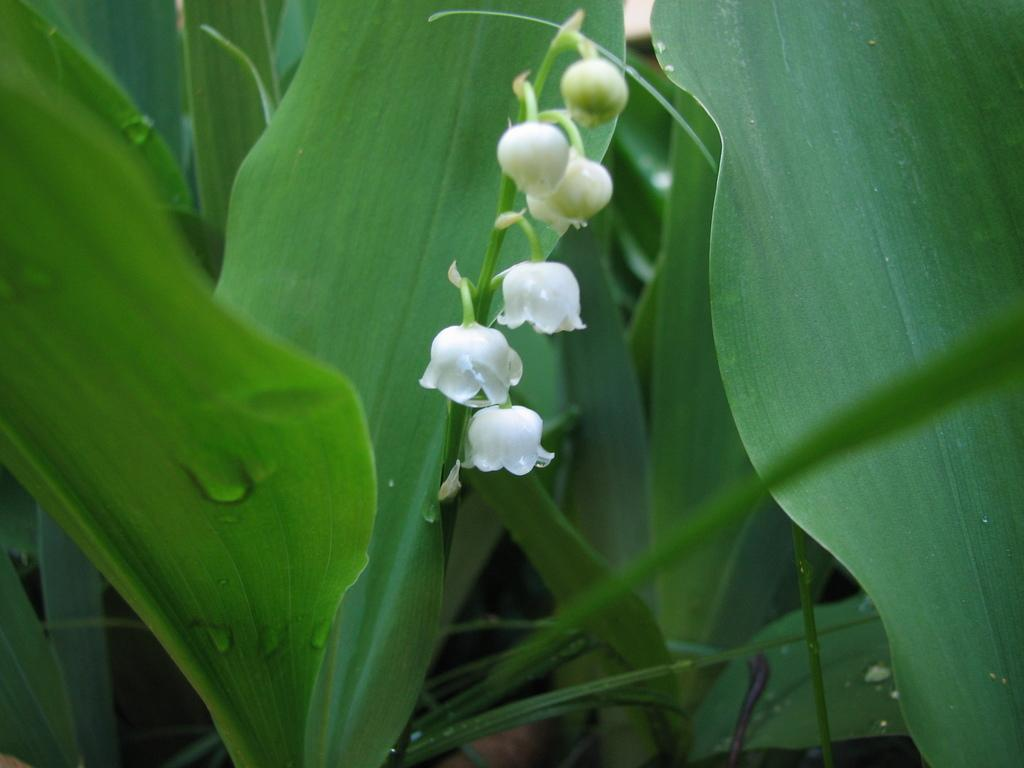What is present in the image? There is a plant in the image. What can be observed about the plant? There are small white flowers on the plant. How many sisters does the plant have in the image? The plant does not have any sisters in the image, as plants do not have siblings. 